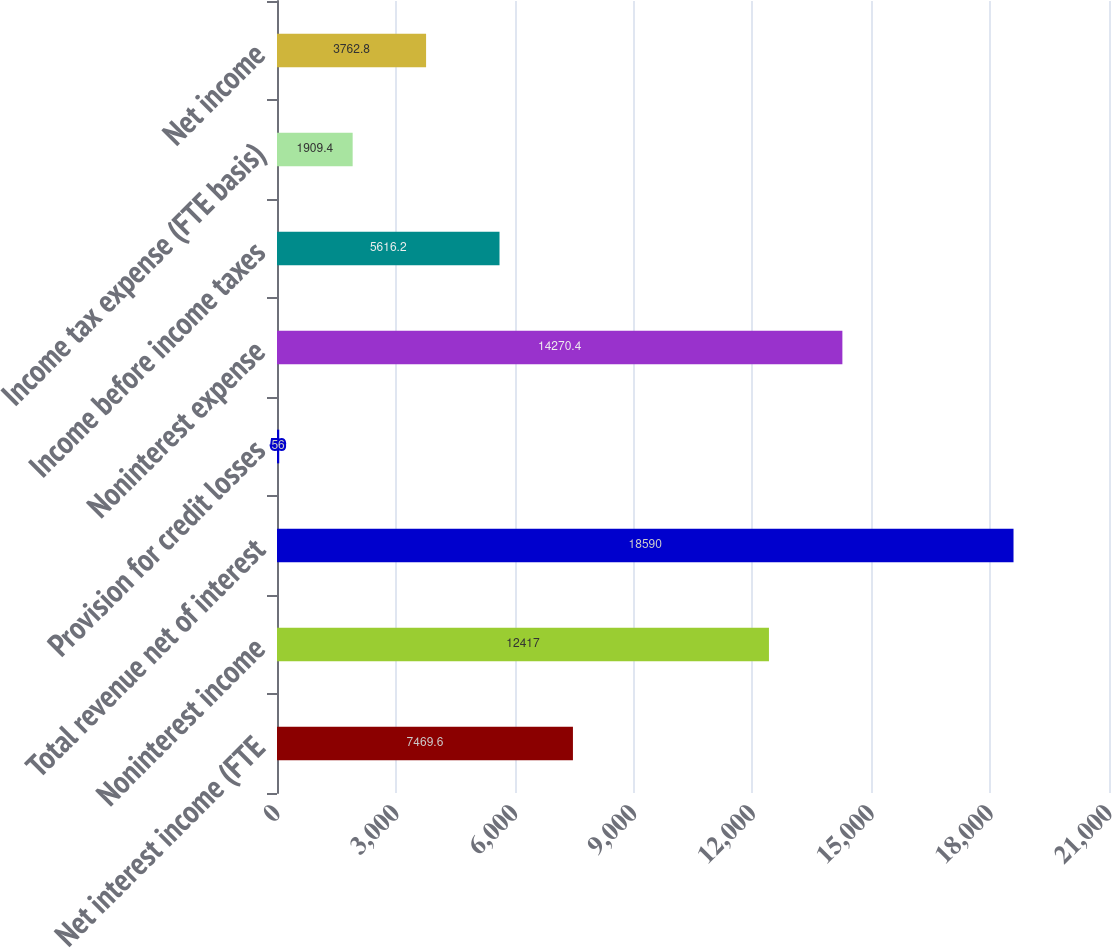<chart> <loc_0><loc_0><loc_500><loc_500><bar_chart><fcel>Net interest income (FTE<fcel>Noninterest income<fcel>Total revenue net of interest<fcel>Provision for credit losses<fcel>Noninterest expense<fcel>Income before income taxes<fcel>Income tax expense (FTE basis)<fcel>Net income<nl><fcel>7469.6<fcel>12417<fcel>18590<fcel>56<fcel>14270.4<fcel>5616.2<fcel>1909.4<fcel>3762.8<nl></chart> 